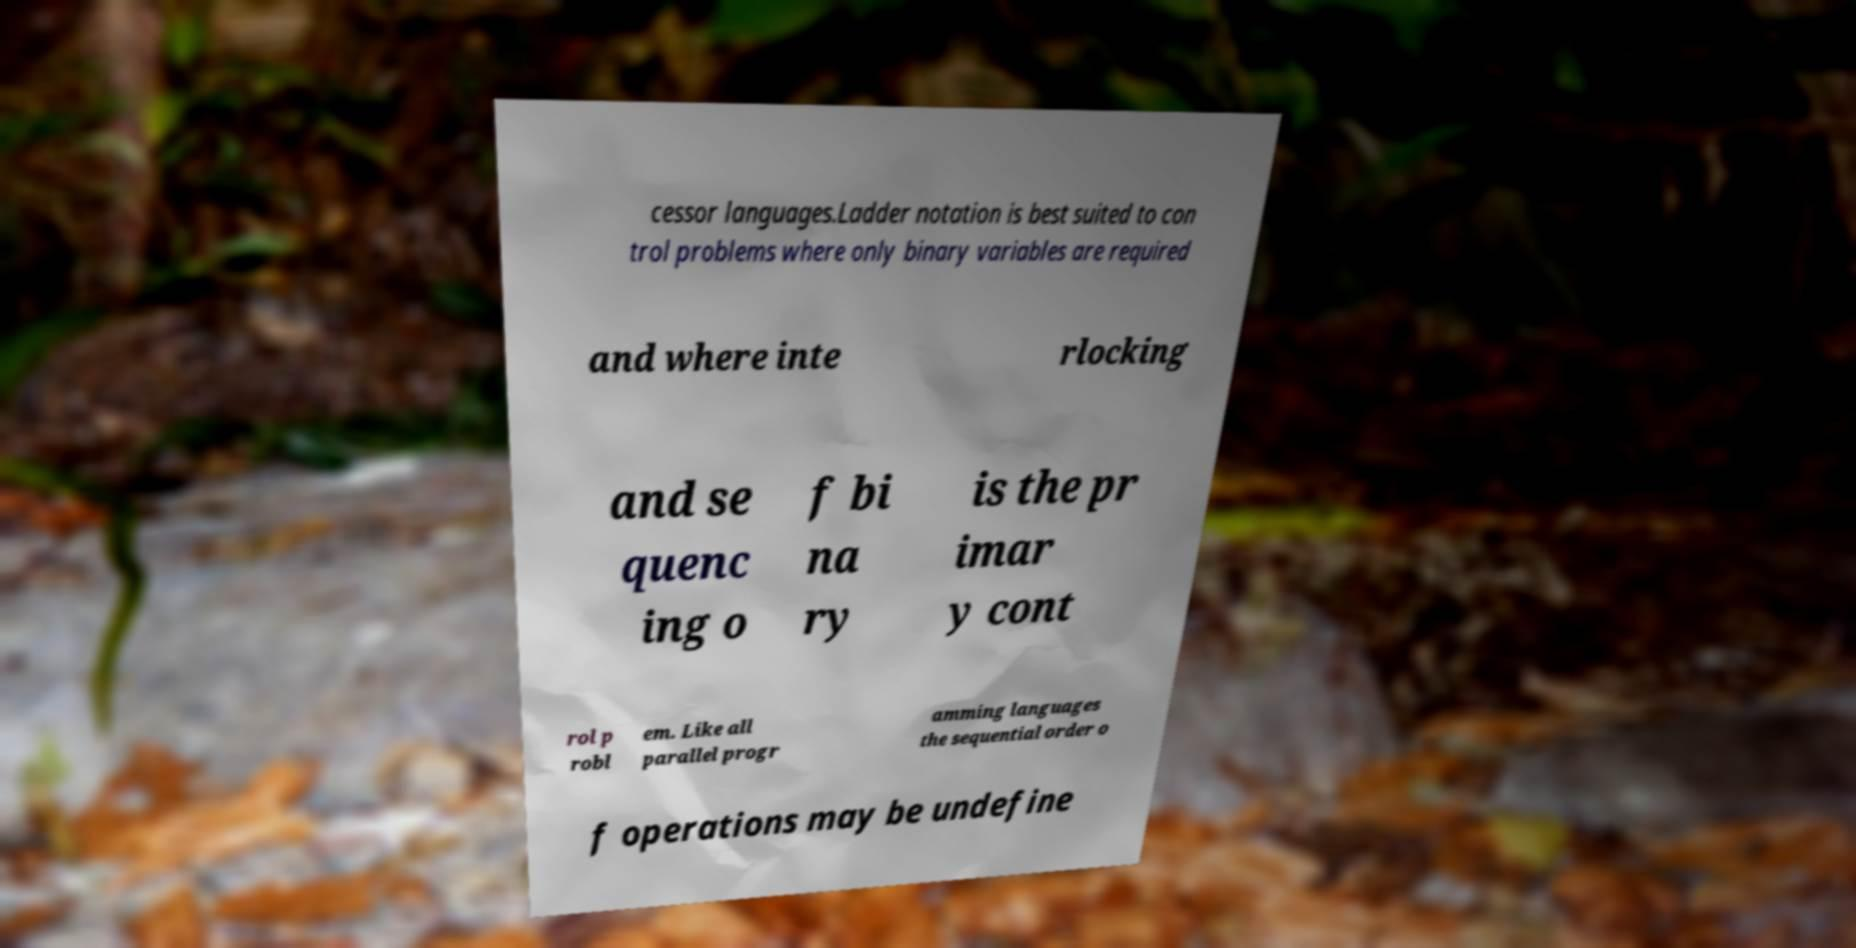There's text embedded in this image that I need extracted. Can you transcribe it verbatim? cessor languages.Ladder notation is best suited to con trol problems where only binary variables are required and where inte rlocking and se quenc ing o f bi na ry is the pr imar y cont rol p robl em. Like all parallel progr amming languages the sequential order o f operations may be undefine 